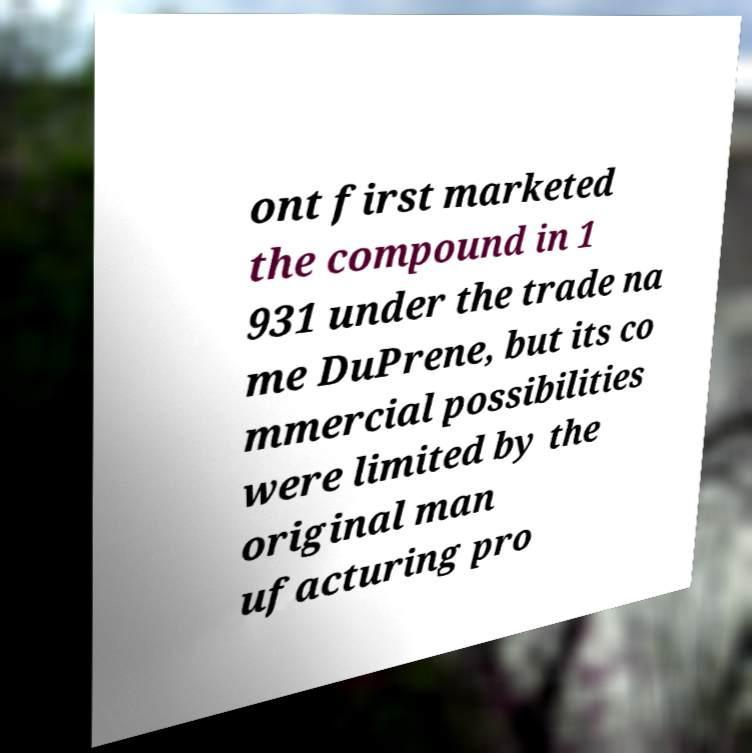Could you assist in decoding the text presented in this image and type it out clearly? ont first marketed the compound in 1 931 under the trade na me DuPrene, but its co mmercial possibilities were limited by the original man ufacturing pro 